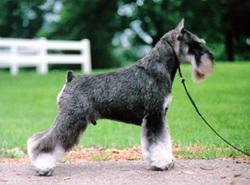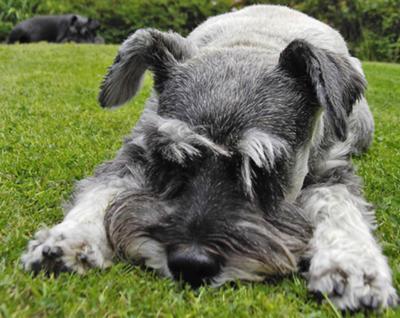The first image is the image on the left, the second image is the image on the right. Evaluate the accuracy of this statement regarding the images: "The dog in the image on the right is standing up on all four.". Is it true? Answer yes or no. No. The first image is the image on the left, the second image is the image on the right. For the images shown, is this caption "A schnauzer on a leash is in profile facing leftward in front of some type of white lattice." true? Answer yes or no. No. 